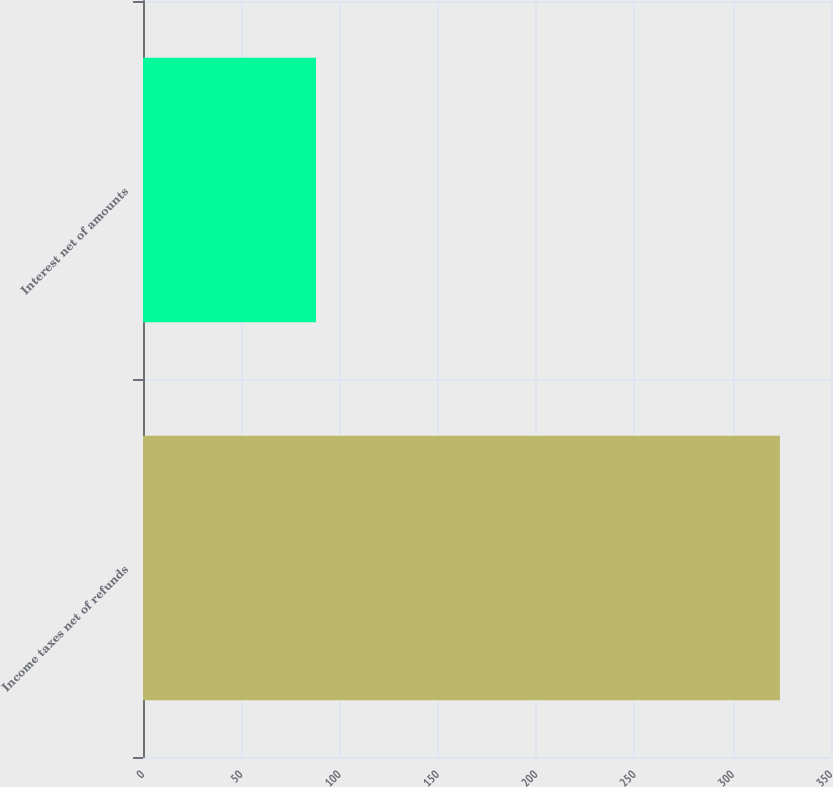Convert chart. <chart><loc_0><loc_0><loc_500><loc_500><bar_chart><fcel>Income taxes net of refunds<fcel>Interest net of amounts<nl><fcel>324<fcel>88<nl></chart> 